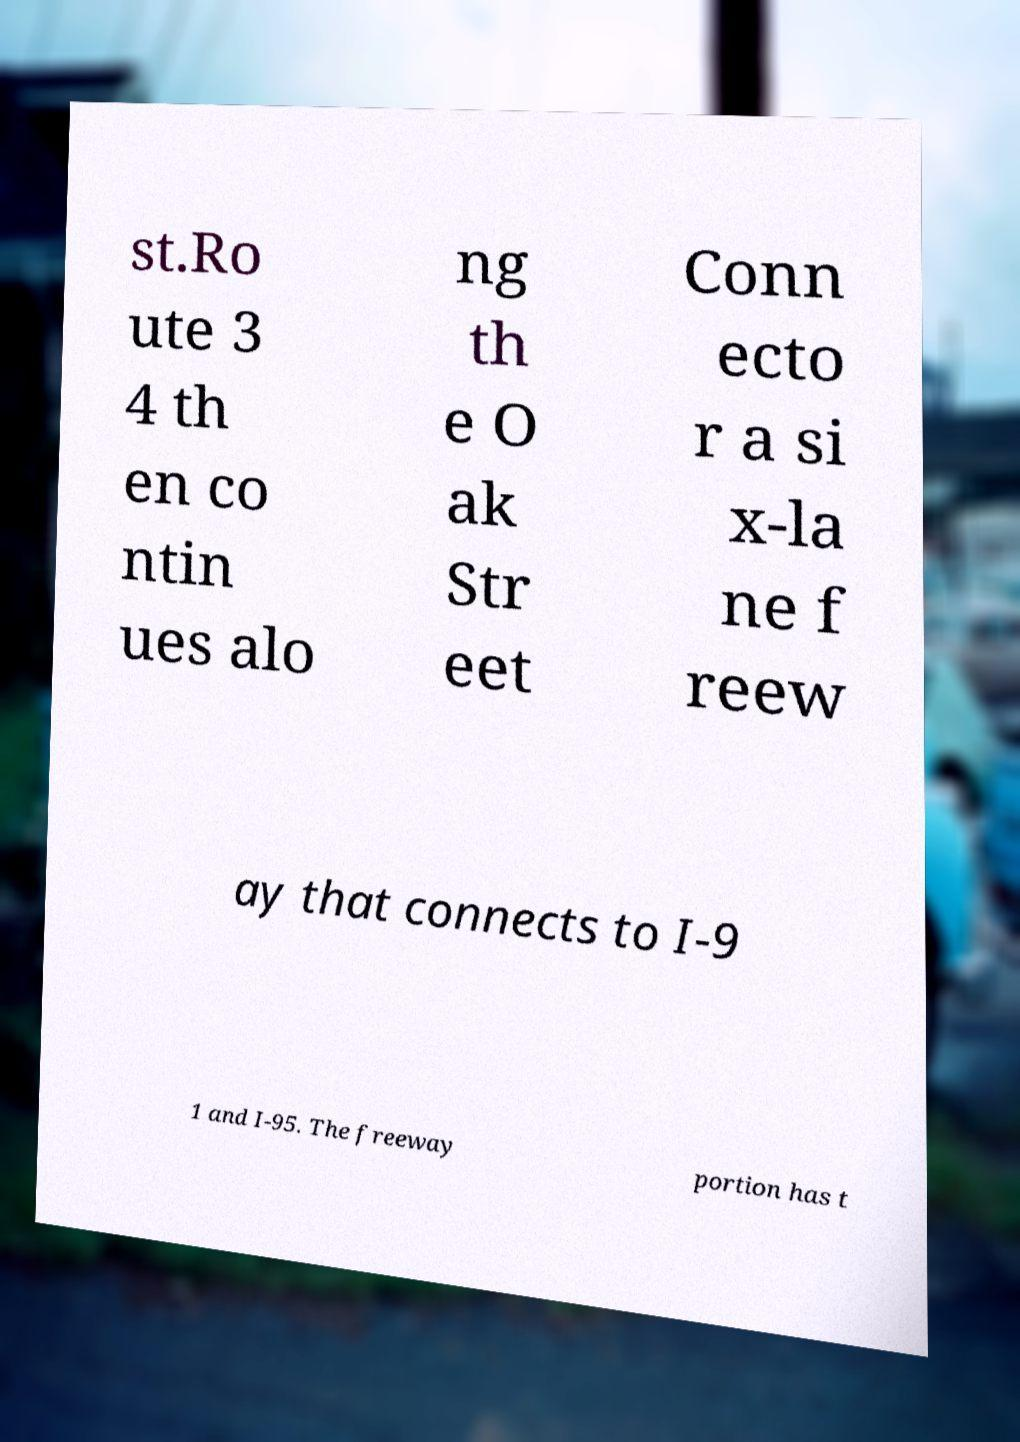Could you extract and type out the text from this image? st.Ro ute 3 4 th en co ntin ues alo ng th e O ak Str eet Conn ecto r a si x-la ne f reew ay that connects to I-9 1 and I-95. The freeway portion has t 